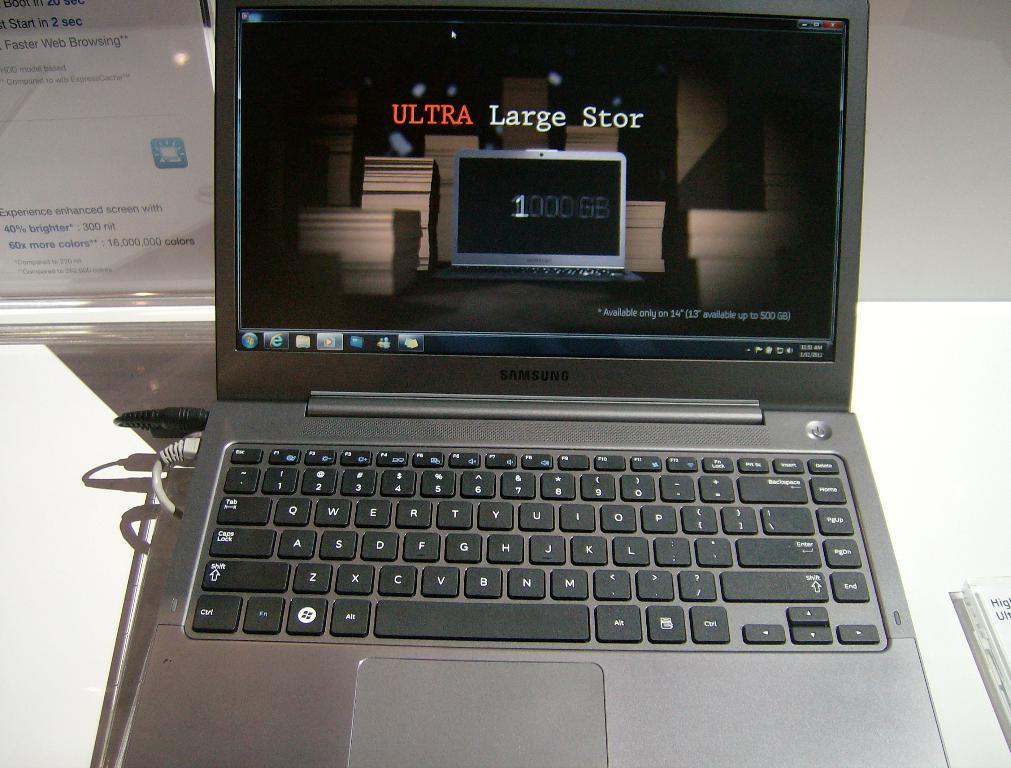Ultra large what?
Give a very brief answer. Stor. What bold word is written in red?
Offer a very short reply. Ultra. 